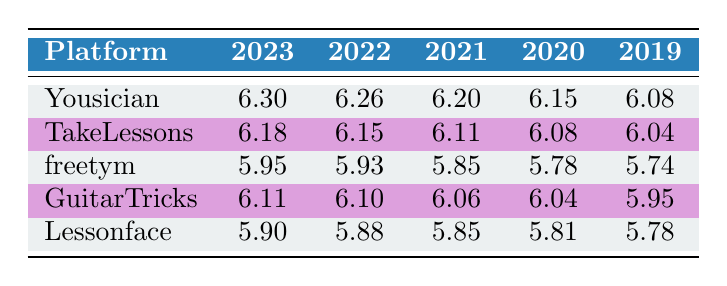What was the revenue from Yousician in 2023? The table shows the revenue for Yousician in the year 2023 as 2,000,000.
Answer: 2,000,000 Which platform had the highest revenue in 2022? By comparing the values in the 2022 column, Yousician has the highest revenue of 1,800,000, while the other platforms have lower values.
Answer: Yousician What was the difference in revenue for GuitarTricks between 2020 and 2021? GuitarTricks had a revenue of 1,100,000 in 2020 and 1,150,000 in 2021. The difference is 1,150,000 - 1,100,000 = 50,000.
Answer: 50,000 Did freetym's revenue increase every year from 2019 to 2023? Looking at the revenue values for freetym, they are 550,000 (2019), 600,000 (2020), 700,000 (2021), 850,000 (2022), and 900,000 (2023). All values show an increase.
Answer: Yes What is the average revenue from online music lessons for all platforms in 2023? The revenues in 2023 are 2,000,000 (Yousician), 1,500,000 (TakeLessons), 900,000 (freetym), 1,300,000 (GuitarTricks), and 800,000 (Lessonface). Summing them gives 2,000,000 + 1,500,000 + 900,000 + 1,300,000 + 800,000 = 6,500,000. Dividing by 5 gives an average of 6,500,000 / 5 = 1,300,000.
Answer: 1,300,000 Which platform consistently had the lowest revenue over the five years shown? By analyzing the revenue over the five years, Lessonface shows the lowest values compared to all other platforms for each of the years listed.
Answer: Lessonface 